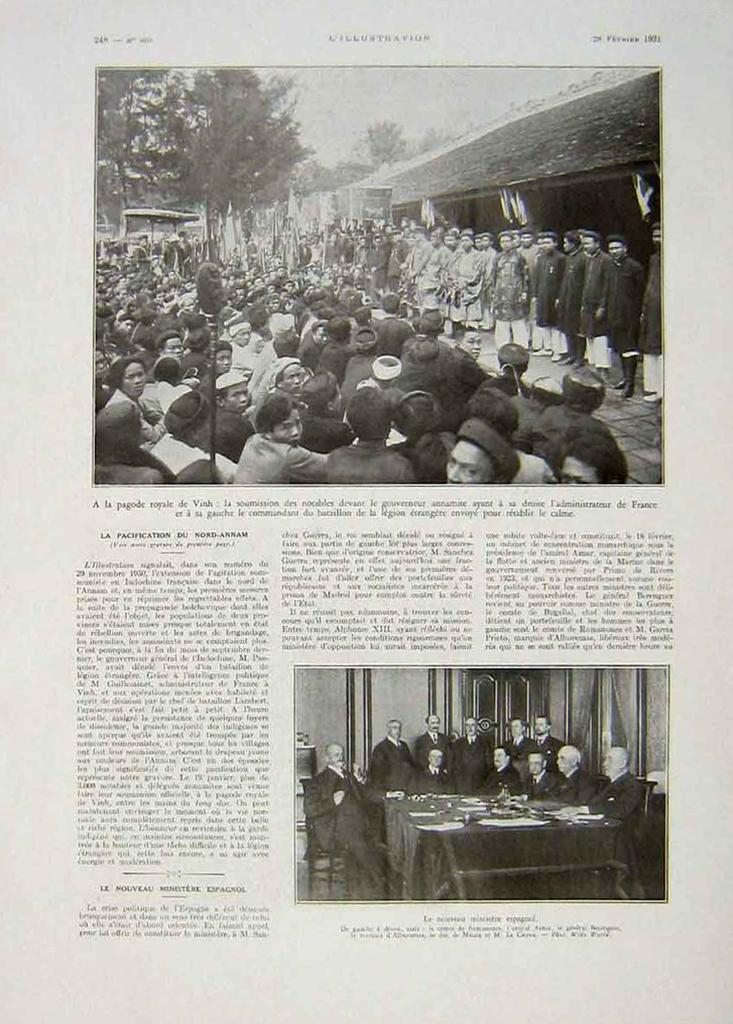What is present on the paper in the image? The paper contains text. What else can be seen in the image besides the paper? There is a group of people and trees in the image. What type of jelly is being used by the lawyer in the image? There is no jelly or lawyer present in the image. How many bubbles can be seen floating around the group of people in the image? There are no bubbles present in the image. 